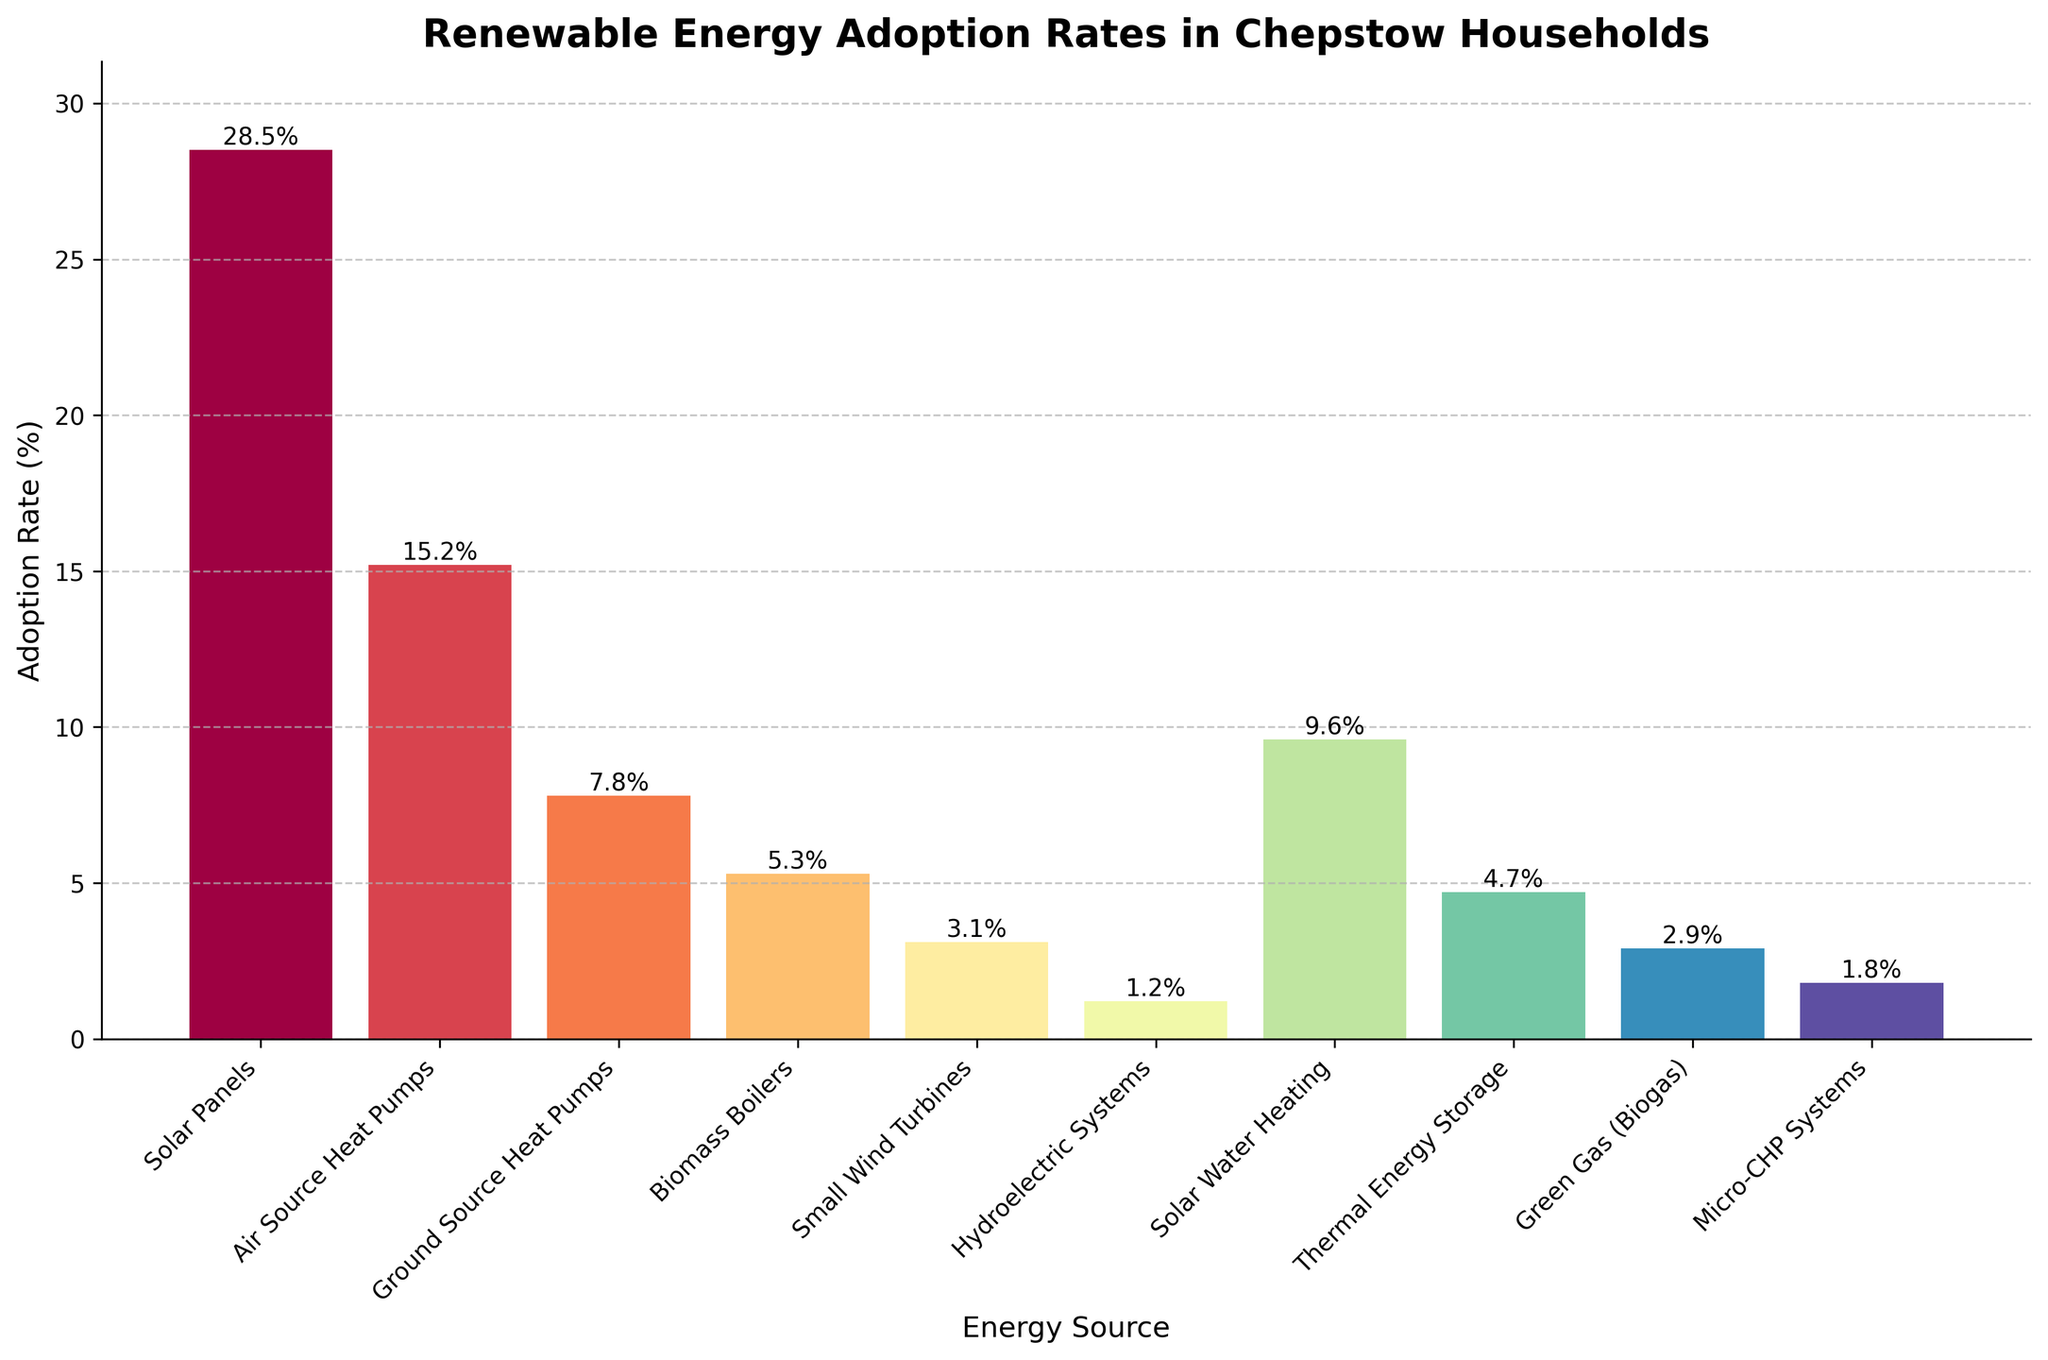What's the highest adoption rate among all renewable energy sources? The highest bar in the chart represents the energy source with the highest adoption rate. The title of the highest bar indicates it is "Solar Panels" with an adoption rate of 28.5%.
Answer: Solar Panels Which renewable energy source has a lower adoption rate, Biomass Boilers or Green Gas (Biogas)? By comparing the heights of the bars for Biomass Boilers and Green Gas (Biogas), it's clear the bar for Green Gas (Biogas) is shorter. Therefore, the adoption rate for Green Gas (Biogas) is lower (2.9%) compared to Biomass Boilers (5.3%).
Answer: Green Gas (Biogas) What is the combined adoption rate for Solar Water Heating and Thermal Energy Storage? Locate the bars for Solar Water Heating and Thermal Energy Storage. The adoption rates are 9.6% and 4.7%, respectively. Adding these two rates: 9.6 + 4.7 = 14.3%.
Answer: 14.3% Which energy source has an adoption rate between 5% and 10%? Identify bars that fall within the range of greater than 5% but less than 10%. Solar Water Heating (9.6%) and Biomass Boilers (5.3%) fall within this range.
Answer: Solar Water Heating, Biomass Boilers What is the difference in adoption rates between Air Source Heat Pumps and Micro-CHP Systems? Locate the bars for Air Source Heat Pumps (15.2%) and Micro-CHP Systems (1.8%). Subtracting the lower rate from the higher rate: 15.2 - 1.8 = 13.4%.
Answer: 13.4% Which energy source has the lowest adoption rate? The shortest bar in the chart represents the energy source with the lowest adoption rate, indicated as "Hydroelectric Systems" with a rate of 1.2%.
Answer: Hydroelectric Systems How many energy sources have an adoption rate greater than 10%? Identify bars that exceed the 10% mark. The energy sources are Solar Panels (28.5%) and Air Source Heat Pumps (15.2%).
Answer: 2 What is the average adoption rate of the listed renewable energy sources? Sum all the adoption rates: (28.5 + 15.2 + 7.8 + 5.3 + 3.1 + 1.2 + 9.6 + 4.7 + 2.9 + 1.8) = 80.1. Divide by the number of sources, 10: 80.1 / 10 = 8.01%.
Answer: 8.01% Which two renewable energy sources have an adoption rate closest to each other? Look for bars with similarly close heights. Thermal Energy Storage (4.7%) and Biomass Boilers (5.3%) are closest, with a difference of 0.6%.
Answer: Thermal Energy Storage and Biomass Boilers 